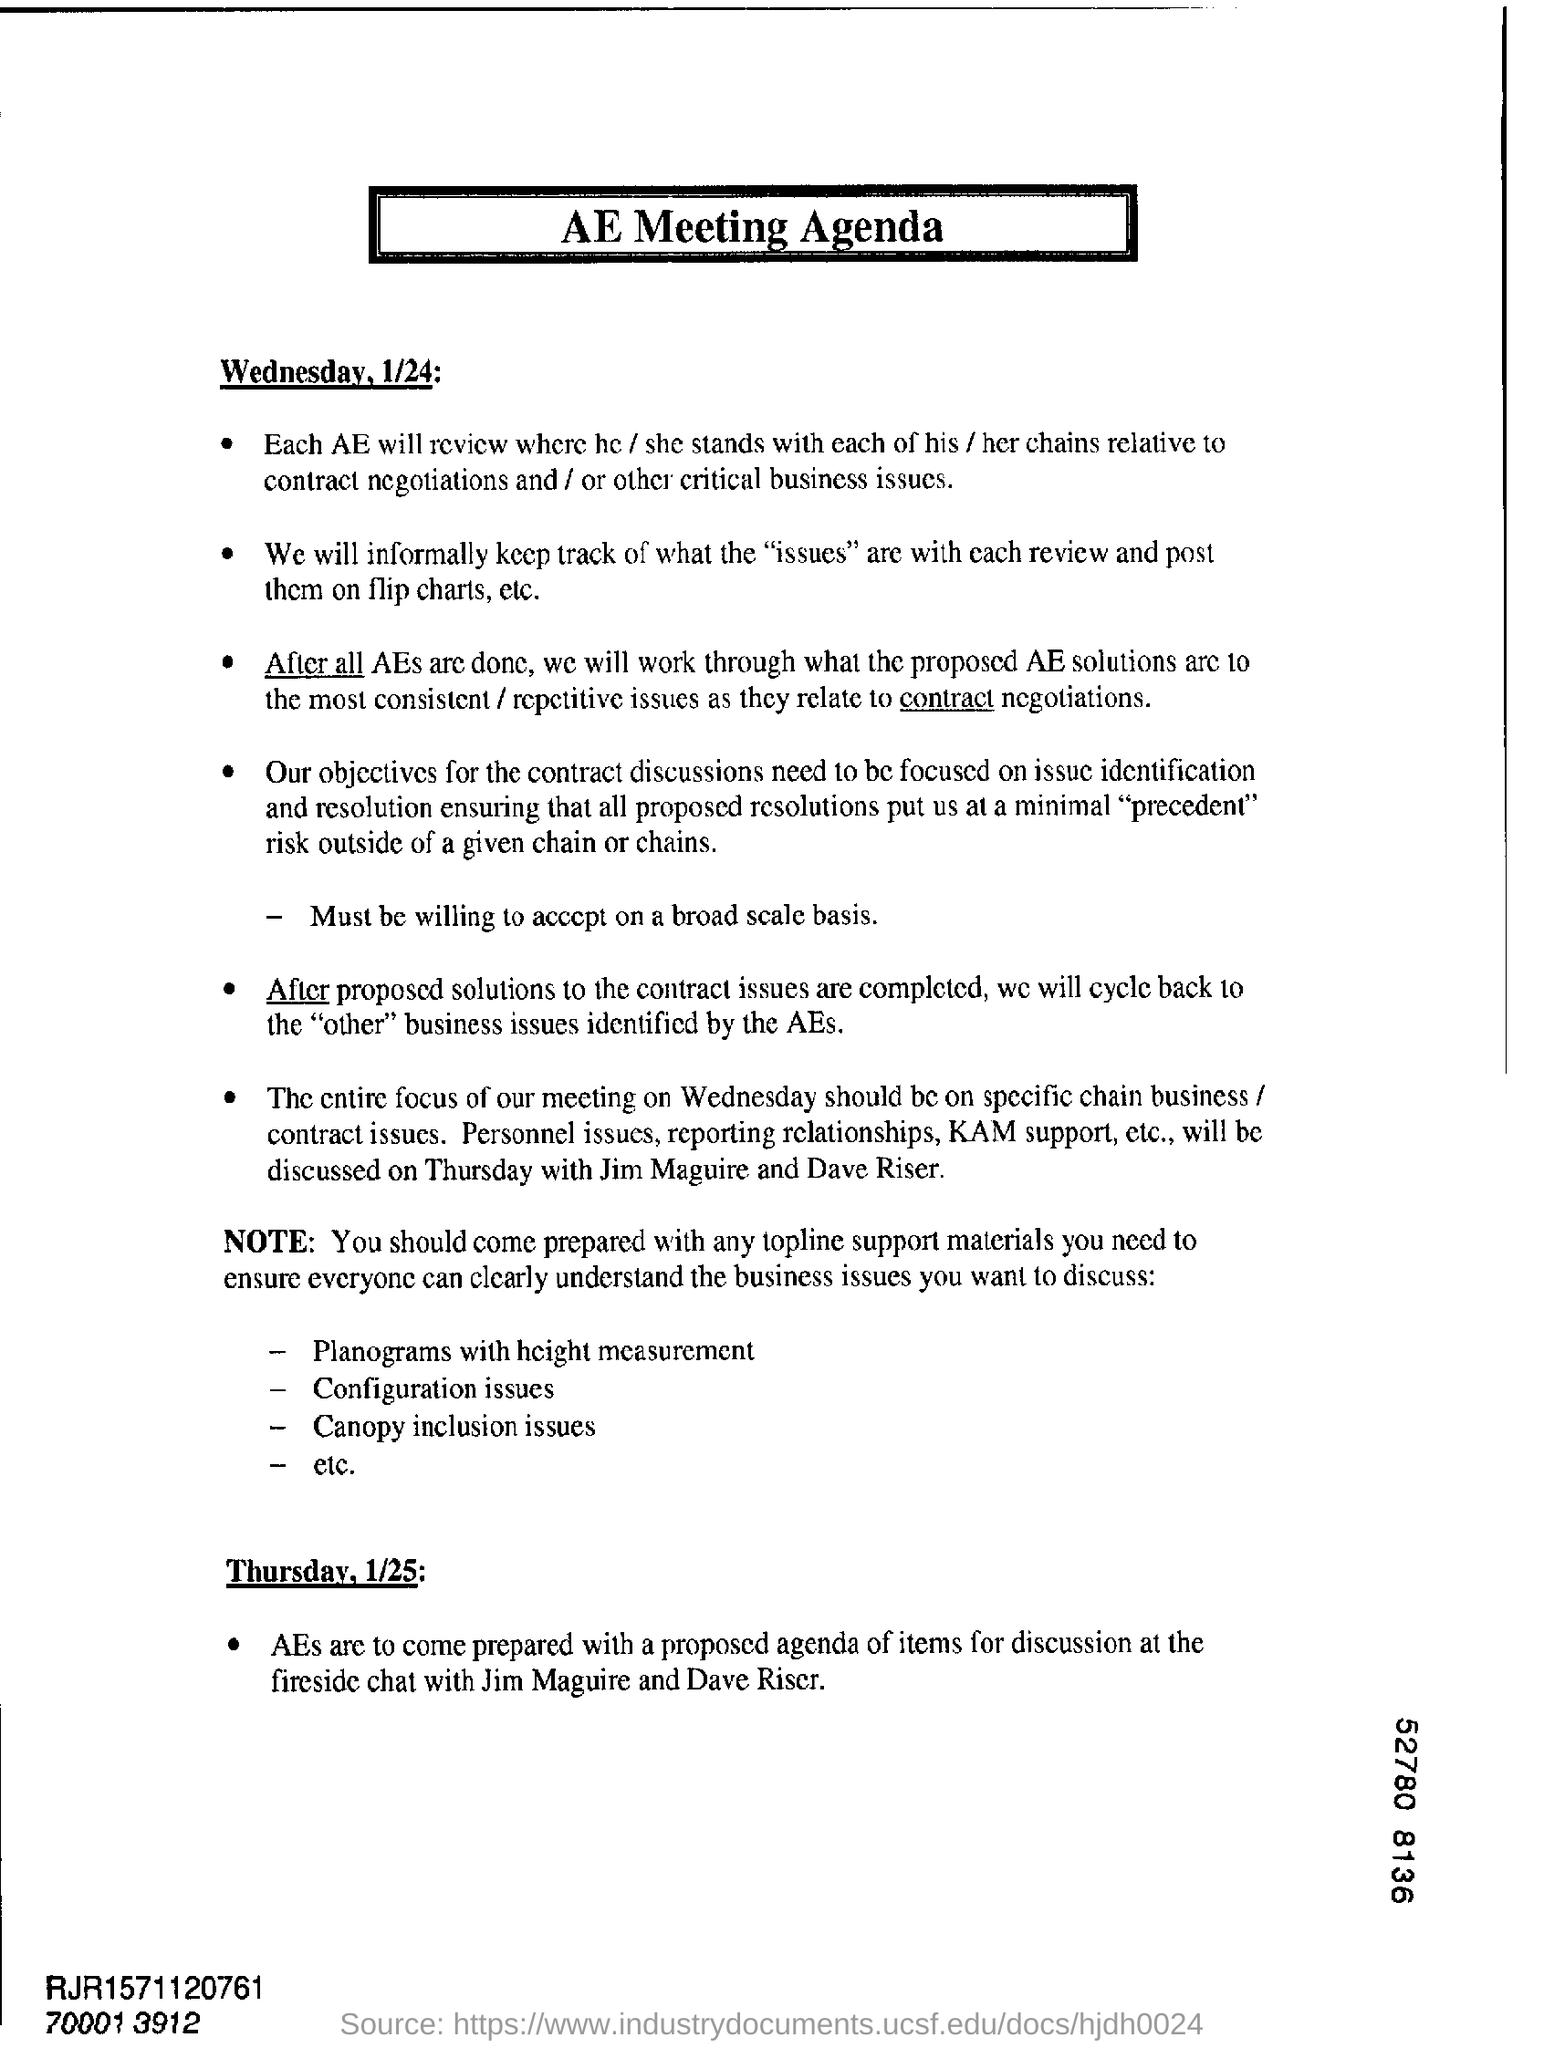Identify some key points in this picture. The agenda mentioned in the document is related to the AE Meeting Agenda. 